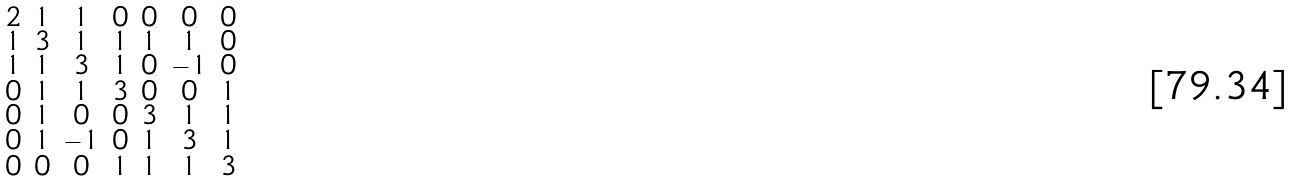<formula> <loc_0><loc_0><loc_500><loc_500>\begin{smallmatrix} 2 & 1 & 1 & 0 & 0 & 0 & 0 \\ 1 & 3 & 1 & 1 & 1 & 1 & 0 \\ 1 & 1 & 3 & 1 & 0 & - 1 & 0 \\ 0 & 1 & 1 & 3 & 0 & 0 & 1 \\ 0 & 1 & 0 & 0 & 3 & 1 & 1 \\ 0 & 1 & - 1 & 0 & 1 & 3 & 1 \\ 0 & 0 & 0 & 1 & 1 & 1 & 3 \end{smallmatrix}</formula> 